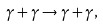Convert formula to latex. <formula><loc_0><loc_0><loc_500><loc_500>\gamma + \gamma \to \gamma + \gamma ,</formula> 